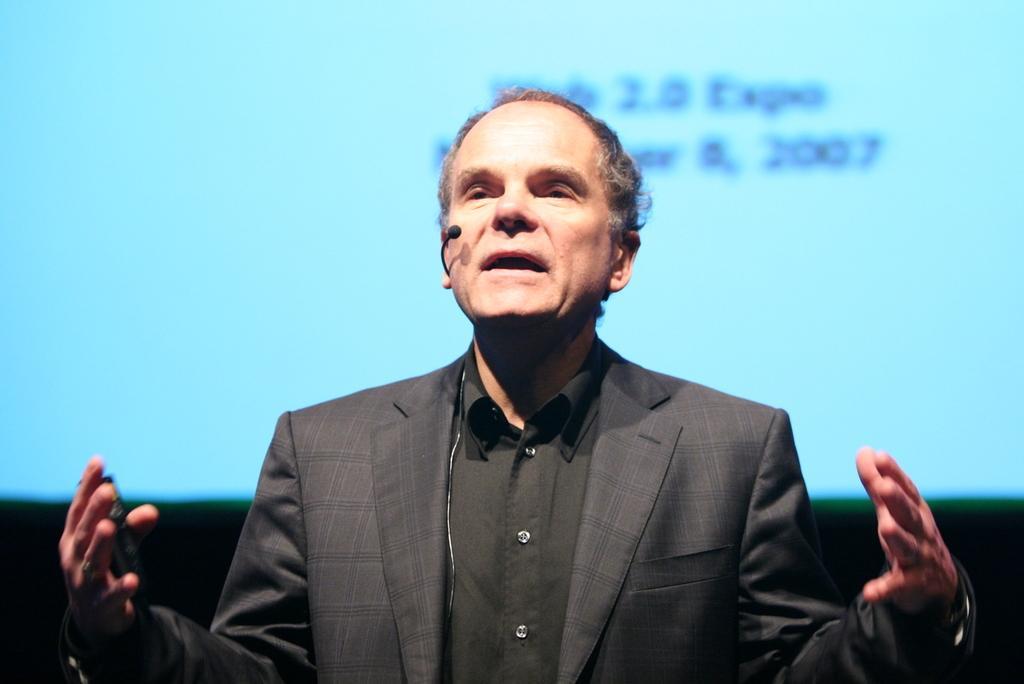Can you describe this image briefly? In this image I can see a man in the front and I can see he is wearing black shirt and black blazer. I can see a mic near his mouth. In the background I can see a screen and on it I can see something is written. I can also see a black colour thing in his hand. 